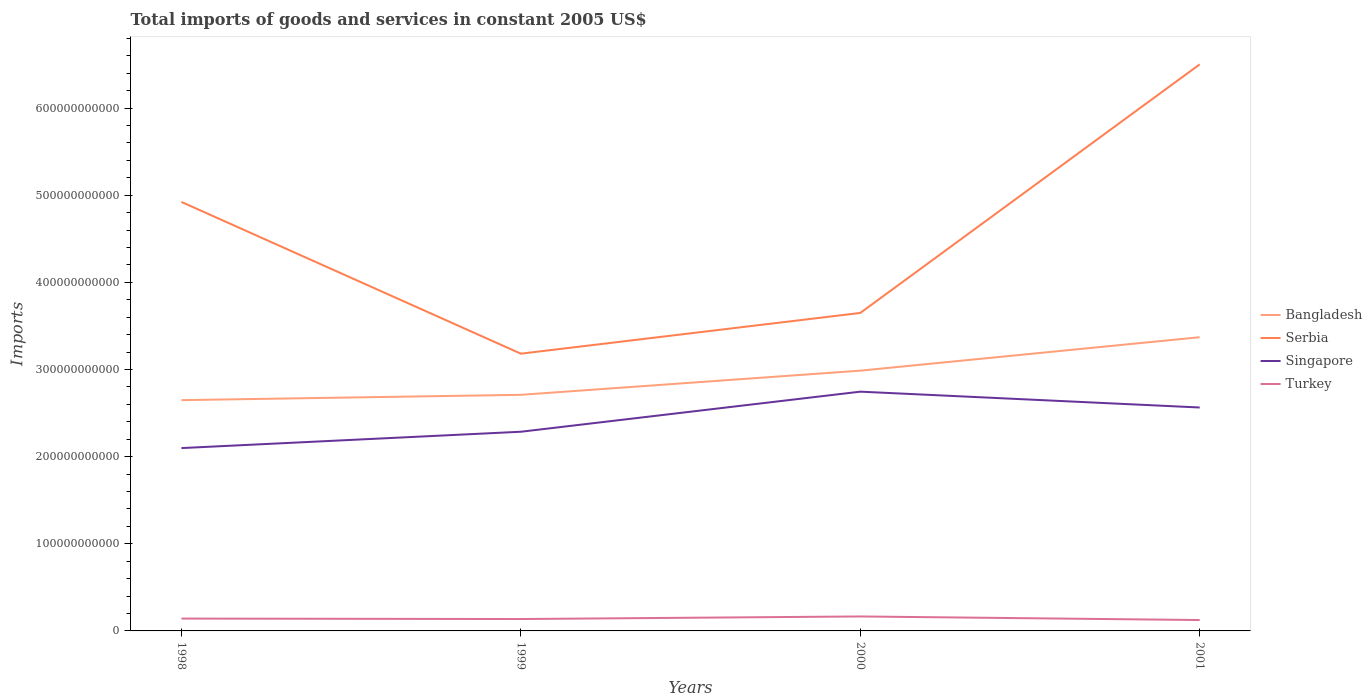How many different coloured lines are there?
Provide a succinct answer. 4. Is the number of lines equal to the number of legend labels?
Ensure brevity in your answer.  Yes. Across all years, what is the maximum total imports of goods and services in Bangladesh?
Ensure brevity in your answer.  2.65e+11. In which year was the total imports of goods and services in Turkey maximum?
Make the answer very short. 2001. What is the total total imports of goods and services in Bangladesh in the graph?
Provide a succinct answer. -3.38e+1. What is the difference between the highest and the second highest total imports of goods and services in Turkey?
Provide a succinct answer. 4.11e+09. Is the total imports of goods and services in Singapore strictly greater than the total imports of goods and services in Turkey over the years?
Provide a succinct answer. No. What is the difference between two consecutive major ticks on the Y-axis?
Make the answer very short. 1.00e+11. How are the legend labels stacked?
Give a very brief answer. Vertical. What is the title of the graph?
Provide a short and direct response. Total imports of goods and services in constant 2005 US$. What is the label or title of the X-axis?
Ensure brevity in your answer.  Years. What is the label or title of the Y-axis?
Provide a short and direct response. Imports. What is the Imports of Bangladesh in 1998?
Give a very brief answer. 2.65e+11. What is the Imports in Serbia in 1998?
Make the answer very short. 4.92e+11. What is the Imports of Singapore in 1998?
Provide a succinct answer. 2.10e+11. What is the Imports of Turkey in 1998?
Keep it short and to the point. 1.42e+1. What is the Imports in Bangladesh in 1999?
Provide a short and direct response. 2.71e+11. What is the Imports in Serbia in 1999?
Ensure brevity in your answer.  3.18e+11. What is the Imports in Singapore in 1999?
Give a very brief answer. 2.29e+11. What is the Imports of Turkey in 1999?
Provide a succinct answer. 1.36e+1. What is the Imports of Bangladesh in 2000?
Your answer should be compact. 2.99e+11. What is the Imports in Serbia in 2000?
Your answer should be compact. 3.65e+11. What is the Imports in Singapore in 2000?
Your answer should be compact. 2.75e+11. What is the Imports in Turkey in 2000?
Ensure brevity in your answer.  1.66e+1. What is the Imports of Bangladesh in 2001?
Ensure brevity in your answer.  3.37e+11. What is the Imports of Serbia in 2001?
Offer a very short reply. 6.50e+11. What is the Imports in Singapore in 2001?
Your answer should be compact. 2.56e+11. What is the Imports of Turkey in 2001?
Your answer should be compact. 1.25e+1. Across all years, what is the maximum Imports of Bangladesh?
Offer a very short reply. 3.37e+11. Across all years, what is the maximum Imports of Serbia?
Offer a very short reply. 6.50e+11. Across all years, what is the maximum Imports in Singapore?
Your response must be concise. 2.75e+11. Across all years, what is the maximum Imports in Turkey?
Keep it short and to the point. 1.66e+1. Across all years, what is the minimum Imports in Bangladesh?
Your answer should be compact. 2.65e+11. Across all years, what is the minimum Imports of Serbia?
Your response must be concise. 3.18e+11. Across all years, what is the minimum Imports in Singapore?
Give a very brief answer. 2.10e+11. Across all years, what is the minimum Imports in Turkey?
Make the answer very short. 1.25e+1. What is the total Imports in Bangladesh in the graph?
Provide a short and direct response. 1.17e+12. What is the total Imports of Serbia in the graph?
Provide a succinct answer. 1.83e+12. What is the total Imports of Singapore in the graph?
Provide a short and direct response. 9.69e+11. What is the total Imports in Turkey in the graph?
Offer a very short reply. 5.69e+1. What is the difference between the Imports of Bangladesh in 1998 and that in 1999?
Offer a very short reply. -6.11e+09. What is the difference between the Imports of Serbia in 1998 and that in 1999?
Give a very brief answer. 1.74e+11. What is the difference between the Imports in Singapore in 1998 and that in 1999?
Your answer should be compact. -1.87e+1. What is the difference between the Imports in Turkey in 1998 and that in 1999?
Give a very brief answer. 5.26e+08. What is the difference between the Imports of Bangladesh in 1998 and that in 2000?
Make the answer very short. -3.38e+1. What is the difference between the Imports of Serbia in 1998 and that in 2000?
Keep it short and to the point. 1.27e+11. What is the difference between the Imports in Singapore in 1998 and that in 2000?
Provide a short and direct response. -6.47e+1. What is the difference between the Imports of Turkey in 1998 and that in 2000?
Keep it short and to the point. -2.44e+09. What is the difference between the Imports in Bangladesh in 1998 and that in 2001?
Your answer should be very brief. -7.22e+1. What is the difference between the Imports of Serbia in 1998 and that in 2001?
Your answer should be very brief. -1.58e+11. What is the difference between the Imports in Singapore in 1998 and that in 2001?
Provide a succinct answer. -4.66e+1. What is the difference between the Imports of Turkey in 1998 and that in 2001?
Your answer should be very brief. 1.67e+09. What is the difference between the Imports of Bangladesh in 1999 and that in 2000?
Offer a terse response. -2.77e+1. What is the difference between the Imports in Serbia in 1999 and that in 2000?
Your response must be concise. -4.67e+1. What is the difference between the Imports in Singapore in 1999 and that in 2000?
Your response must be concise. -4.60e+1. What is the difference between the Imports in Turkey in 1999 and that in 2000?
Offer a very short reply. -2.97e+09. What is the difference between the Imports in Bangladesh in 1999 and that in 2001?
Keep it short and to the point. -6.61e+1. What is the difference between the Imports in Serbia in 1999 and that in 2001?
Ensure brevity in your answer.  -3.32e+11. What is the difference between the Imports in Singapore in 1999 and that in 2001?
Your answer should be compact. -2.78e+1. What is the difference between the Imports of Turkey in 1999 and that in 2001?
Keep it short and to the point. 1.14e+09. What is the difference between the Imports in Bangladesh in 2000 and that in 2001?
Give a very brief answer. -3.84e+1. What is the difference between the Imports of Serbia in 2000 and that in 2001?
Offer a very short reply. -2.85e+11. What is the difference between the Imports in Singapore in 2000 and that in 2001?
Offer a terse response. 1.82e+1. What is the difference between the Imports of Turkey in 2000 and that in 2001?
Ensure brevity in your answer.  4.11e+09. What is the difference between the Imports in Bangladesh in 1998 and the Imports in Serbia in 1999?
Provide a short and direct response. -5.33e+1. What is the difference between the Imports of Bangladesh in 1998 and the Imports of Singapore in 1999?
Give a very brief answer. 3.63e+1. What is the difference between the Imports of Bangladesh in 1998 and the Imports of Turkey in 1999?
Your response must be concise. 2.51e+11. What is the difference between the Imports in Serbia in 1998 and the Imports in Singapore in 1999?
Make the answer very short. 2.64e+11. What is the difference between the Imports in Serbia in 1998 and the Imports in Turkey in 1999?
Your answer should be compact. 4.79e+11. What is the difference between the Imports in Singapore in 1998 and the Imports in Turkey in 1999?
Ensure brevity in your answer.  1.96e+11. What is the difference between the Imports in Bangladesh in 1998 and the Imports in Serbia in 2000?
Keep it short and to the point. -1.00e+11. What is the difference between the Imports in Bangladesh in 1998 and the Imports in Singapore in 2000?
Your answer should be very brief. -9.73e+09. What is the difference between the Imports in Bangladesh in 1998 and the Imports in Turkey in 2000?
Offer a very short reply. 2.48e+11. What is the difference between the Imports in Serbia in 1998 and the Imports in Singapore in 2000?
Ensure brevity in your answer.  2.18e+11. What is the difference between the Imports of Serbia in 1998 and the Imports of Turkey in 2000?
Make the answer very short. 4.76e+11. What is the difference between the Imports in Singapore in 1998 and the Imports in Turkey in 2000?
Keep it short and to the point. 1.93e+11. What is the difference between the Imports of Bangladesh in 1998 and the Imports of Serbia in 2001?
Your answer should be very brief. -3.85e+11. What is the difference between the Imports in Bangladesh in 1998 and the Imports in Singapore in 2001?
Make the answer very short. 8.44e+09. What is the difference between the Imports in Bangladesh in 1998 and the Imports in Turkey in 2001?
Ensure brevity in your answer.  2.52e+11. What is the difference between the Imports in Serbia in 1998 and the Imports in Singapore in 2001?
Offer a terse response. 2.36e+11. What is the difference between the Imports in Serbia in 1998 and the Imports in Turkey in 2001?
Your response must be concise. 4.80e+11. What is the difference between the Imports of Singapore in 1998 and the Imports of Turkey in 2001?
Your answer should be compact. 1.97e+11. What is the difference between the Imports of Bangladesh in 1999 and the Imports of Serbia in 2000?
Keep it short and to the point. -9.40e+1. What is the difference between the Imports of Bangladesh in 1999 and the Imports of Singapore in 2000?
Offer a very short reply. -3.63e+09. What is the difference between the Imports of Bangladesh in 1999 and the Imports of Turkey in 2000?
Provide a succinct answer. 2.54e+11. What is the difference between the Imports in Serbia in 1999 and the Imports in Singapore in 2000?
Keep it short and to the point. 4.36e+1. What is the difference between the Imports in Serbia in 1999 and the Imports in Turkey in 2000?
Offer a terse response. 3.02e+11. What is the difference between the Imports in Singapore in 1999 and the Imports in Turkey in 2000?
Offer a very short reply. 2.12e+11. What is the difference between the Imports in Bangladesh in 1999 and the Imports in Serbia in 2001?
Your answer should be compact. -3.79e+11. What is the difference between the Imports of Bangladesh in 1999 and the Imports of Singapore in 2001?
Your answer should be compact. 1.45e+1. What is the difference between the Imports of Bangladesh in 1999 and the Imports of Turkey in 2001?
Offer a very short reply. 2.58e+11. What is the difference between the Imports of Serbia in 1999 and the Imports of Singapore in 2001?
Your answer should be very brief. 6.18e+1. What is the difference between the Imports of Serbia in 1999 and the Imports of Turkey in 2001?
Offer a terse response. 3.06e+11. What is the difference between the Imports in Singapore in 1999 and the Imports in Turkey in 2001?
Your answer should be very brief. 2.16e+11. What is the difference between the Imports of Bangladesh in 2000 and the Imports of Serbia in 2001?
Give a very brief answer. -3.52e+11. What is the difference between the Imports of Bangladesh in 2000 and the Imports of Singapore in 2001?
Offer a terse response. 4.23e+1. What is the difference between the Imports of Bangladesh in 2000 and the Imports of Turkey in 2001?
Ensure brevity in your answer.  2.86e+11. What is the difference between the Imports in Serbia in 2000 and the Imports in Singapore in 2001?
Provide a succinct answer. 1.08e+11. What is the difference between the Imports in Serbia in 2000 and the Imports in Turkey in 2001?
Give a very brief answer. 3.52e+11. What is the difference between the Imports in Singapore in 2000 and the Imports in Turkey in 2001?
Make the answer very short. 2.62e+11. What is the average Imports in Bangladesh per year?
Your answer should be very brief. 2.93e+11. What is the average Imports in Serbia per year?
Give a very brief answer. 4.56e+11. What is the average Imports in Singapore per year?
Make the answer very short. 2.42e+11. What is the average Imports in Turkey per year?
Ensure brevity in your answer.  1.42e+1. In the year 1998, what is the difference between the Imports in Bangladesh and Imports in Serbia?
Provide a succinct answer. -2.27e+11. In the year 1998, what is the difference between the Imports of Bangladesh and Imports of Singapore?
Provide a short and direct response. 5.50e+1. In the year 1998, what is the difference between the Imports in Bangladesh and Imports in Turkey?
Your answer should be very brief. 2.51e+11. In the year 1998, what is the difference between the Imports in Serbia and Imports in Singapore?
Offer a terse response. 2.82e+11. In the year 1998, what is the difference between the Imports in Serbia and Imports in Turkey?
Give a very brief answer. 4.78e+11. In the year 1998, what is the difference between the Imports of Singapore and Imports of Turkey?
Offer a very short reply. 1.96e+11. In the year 1999, what is the difference between the Imports in Bangladesh and Imports in Serbia?
Provide a short and direct response. -4.72e+1. In the year 1999, what is the difference between the Imports in Bangladesh and Imports in Singapore?
Your answer should be compact. 4.24e+1. In the year 1999, what is the difference between the Imports in Bangladesh and Imports in Turkey?
Offer a terse response. 2.57e+11. In the year 1999, what is the difference between the Imports in Serbia and Imports in Singapore?
Your answer should be very brief. 8.96e+1. In the year 1999, what is the difference between the Imports in Serbia and Imports in Turkey?
Your answer should be very brief. 3.05e+11. In the year 1999, what is the difference between the Imports in Singapore and Imports in Turkey?
Keep it short and to the point. 2.15e+11. In the year 2000, what is the difference between the Imports of Bangladesh and Imports of Serbia?
Provide a short and direct response. -6.62e+1. In the year 2000, what is the difference between the Imports in Bangladesh and Imports in Singapore?
Give a very brief answer. 2.41e+1. In the year 2000, what is the difference between the Imports in Bangladesh and Imports in Turkey?
Offer a terse response. 2.82e+11. In the year 2000, what is the difference between the Imports in Serbia and Imports in Singapore?
Provide a short and direct response. 9.03e+1. In the year 2000, what is the difference between the Imports in Serbia and Imports in Turkey?
Ensure brevity in your answer.  3.48e+11. In the year 2000, what is the difference between the Imports in Singapore and Imports in Turkey?
Give a very brief answer. 2.58e+11. In the year 2001, what is the difference between the Imports of Bangladesh and Imports of Serbia?
Your answer should be very brief. -3.13e+11. In the year 2001, what is the difference between the Imports of Bangladesh and Imports of Singapore?
Offer a terse response. 8.07e+1. In the year 2001, what is the difference between the Imports of Bangladesh and Imports of Turkey?
Your response must be concise. 3.25e+11. In the year 2001, what is the difference between the Imports in Serbia and Imports in Singapore?
Provide a short and direct response. 3.94e+11. In the year 2001, what is the difference between the Imports of Serbia and Imports of Turkey?
Make the answer very short. 6.38e+11. In the year 2001, what is the difference between the Imports in Singapore and Imports in Turkey?
Your answer should be compact. 2.44e+11. What is the ratio of the Imports in Bangladesh in 1998 to that in 1999?
Make the answer very short. 0.98. What is the ratio of the Imports in Serbia in 1998 to that in 1999?
Offer a very short reply. 1.55. What is the ratio of the Imports of Singapore in 1998 to that in 1999?
Offer a terse response. 0.92. What is the ratio of the Imports in Turkey in 1998 to that in 1999?
Provide a short and direct response. 1.04. What is the ratio of the Imports of Bangladesh in 1998 to that in 2000?
Offer a terse response. 0.89. What is the ratio of the Imports in Serbia in 1998 to that in 2000?
Give a very brief answer. 1.35. What is the ratio of the Imports of Singapore in 1998 to that in 2000?
Your response must be concise. 0.76. What is the ratio of the Imports of Turkey in 1998 to that in 2000?
Provide a succinct answer. 0.85. What is the ratio of the Imports of Bangladesh in 1998 to that in 2001?
Provide a succinct answer. 0.79. What is the ratio of the Imports in Serbia in 1998 to that in 2001?
Offer a very short reply. 0.76. What is the ratio of the Imports of Singapore in 1998 to that in 2001?
Provide a succinct answer. 0.82. What is the ratio of the Imports of Turkey in 1998 to that in 2001?
Your answer should be very brief. 1.13. What is the ratio of the Imports of Bangladesh in 1999 to that in 2000?
Your answer should be very brief. 0.91. What is the ratio of the Imports in Serbia in 1999 to that in 2000?
Offer a terse response. 0.87. What is the ratio of the Imports in Singapore in 1999 to that in 2000?
Provide a succinct answer. 0.83. What is the ratio of the Imports of Turkey in 1999 to that in 2000?
Your answer should be very brief. 0.82. What is the ratio of the Imports in Bangladesh in 1999 to that in 2001?
Make the answer very short. 0.8. What is the ratio of the Imports in Serbia in 1999 to that in 2001?
Your response must be concise. 0.49. What is the ratio of the Imports in Singapore in 1999 to that in 2001?
Ensure brevity in your answer.  0.89. What is the ratio of the Imports of Turkey in 1999 to that in 2001?
Provide a short and direct response. 1.09. What is the ratio of the Imports of Bangladesh in 2000 to that in 2001?
Offer a terse response. 0.89. What is the ratio of the Imports of Serbia in 2000 to that in 2001?
Provide a short and direct response. 0.56. What is the ratio of the Imports in Singapore in 2000 to that in 2001?
Ensure brevity in your answer.  1.07. What is the ratio of the Imports of Turkey in 2000 to that in 2001?
Provide a short and direct response. 1.33. What is the difference between the highest and the second highest Imports in Bangladesh?
Your answer should be compact. 3.84e+1. What is the difference between the highest and the second highest Imports of Serbia?
Offer a very short reply. 1.58e+11. What is the difference between the highest and the second highest Imports of Singapore?
Your response must be concise. 1.82e+1. What is the difference between the highest and the second highest Imports of Turkey?
Your answer should be very brief. 2.44e+09. What is the difference between the highest and the lowest Imports in Bangladesh?
Provide a short and direct response. 7.22e+1. What is the difference between the highest and the lowest Imports in Serbia?
Your answer should be compact. 3.32e+11. What is the difference between the highest and the lowest Imports in Singapore?
Offer a terse response. 6.47e+1. What is the difference between the highest and the lowest Imports of Turkey?
Your answer should be compact. 4.11e+09. 